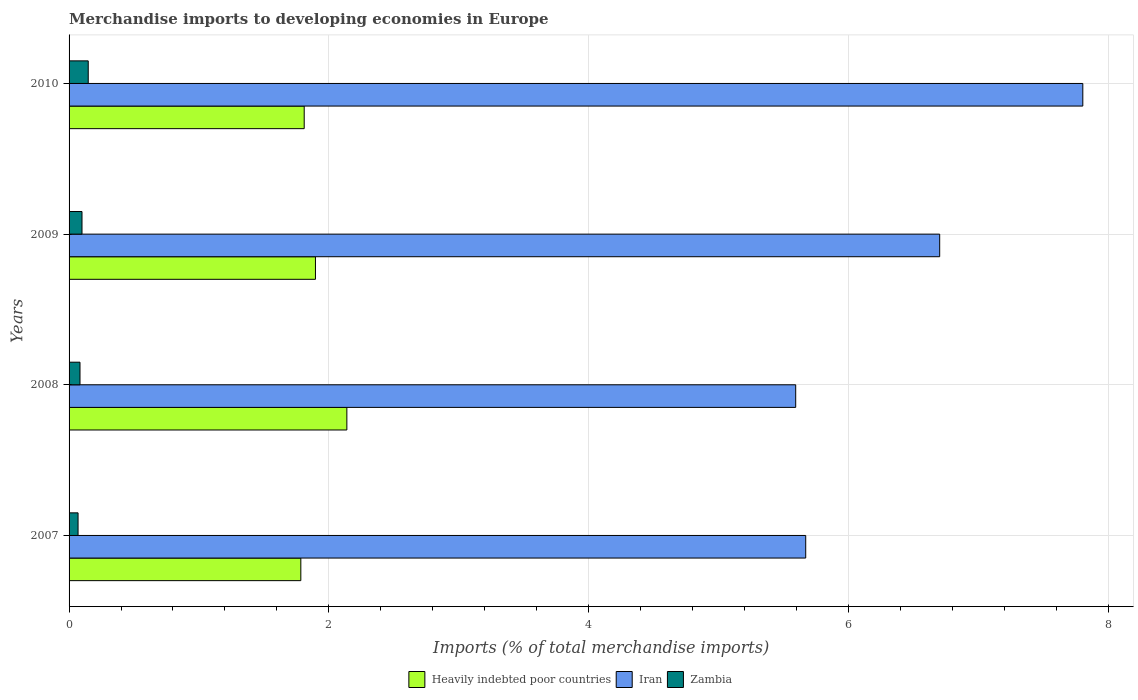Are the number of bars per tick equal to the number of legend labels?
Offer a terse response. Yes. What is the label of the 2nd group of bars from the top?
Keep it short and to the point. 2009. What is the percentage total merchandise imports in Heavily indebted poor countries in 2010?
Give a very brief answer. 1.81. Across all years, what is the maximum percentage total merchandise imports in Zambia?
Make the answer very short. 0.15. Across all years, what is the minimum percentage total merchandise imports in Zambia?
Give a very brief answer. 0.07. In which year was the percentage total merchandise imports in Zambia maximum?
Your response must be concise. 2010. In which year was the percentage total merchandise imports in Zambia minimum?
Offer a terse response. 2007. What is the total percentage total merchandise imports in Iran in the graph?
Make the answer very short. 25.78. What is the difference between the percentage total merchandise imports in Heavily indebted poor countries in 2007 and that in 2010?
Ensure brevity in your answer.  -0.03. What is the difference between the percentage total merchandise imports in Zambia in 2008 and the percentage total merchandise imports in Iran in 2007?
Provide a succinct answer. -5.59. What is the average percentage total merchandise imports in Iran per year?
Your response must be concise. 6.44. In the year 2010, what is the difference between the percentage total merchandise imports in Heavily indebted poor countries and percentage total merchandise imports in Iran?
Ensure brevity in your answer.  -6. In how many years, is the percentage total merchandise imports in Zambia greater than 6.4 %?
Offer a terse response. 0. What is the ratio of the percentage total merchandise imports in Heavily indebted poor countries in 2008 to that in 2010?
Make the answer very short. 1.18. Is the percentage total merchandise imports in Iran in 2007 less than that in 2010?
Ensure brevity in your answer.  Yes. What is the difference between the highest and the second highest percentage total merchandise imports in Iran?
Your answer should be compact. 1.1. What is the difference between the highest and the lowest percentage total merchandise imports in Zambia?
Ensure brevity in your answer.  0.08. Is the sum of the percentage total merchandise imports in Iran in 2007 and 2009 greater than the maximum percentage total merchandise imports in Heavily indebted poor countries across all years?
Your response must be concise. Yes. What does the 1st bar from the top in 2010 represents?
Provide a succinct answer. Zambia. What does the 3rd bar from the bottom in 2010 represents?
Make the answer very short. Zambia. How many bars are there?
Make the answer very short. 12. Does the graph contain grids?
Your response must be concise. Yes. What is the title of the graph?
Your response must be concise. Merchandise imports to developing economies in Europe. Does "Central Europe" appear as one of the legend labels in the graph?
Provide a short and direct response. No. What is the label or title of the X-axis?
Ensure brevity in your answer.  Imports (% of total merchandise imports). What is the label or title of the Y-axis?
Offer a very short reply. Years. What is the Imports (% of total merchandise imports) of Heavily indebted poor countries in 2007?
Your answer should be very brief. 1.78. What is the Imports (% of total merchandise imports) of Iran in 2007?
Make the answer very short. 5.67. What is the Imports (% of total merchandise imports) of Zambia in 2007?
Keep it short and to the point. 0.07. What is the Imports (% of total merchandise imports) in Heavily indebted poor countries in 2008?
Your answer should be very brief. 2.14. What is the Imports (% of total merchandise imports) in Iran in 2008?
Offer a very short reply. 5.6. What is the Imports (% of total merchandise imports) of Zambia in 2008?
Provide a short and direct response. 0.08. What is the Imports (% of total merchandise imports) of Heavily indebted poor countries in 2009?
Offer a very short reply. 1.9. What is the Imports (% of total merchandise imports) in Iran in 2009?
Your answer should be very brief. 6.7. What is the Imports (% of total merchandise imports) of Zambia in 2009?
Your response must be concise. 0.1. What is the Imports (% of total merchandise imports) in Heavily indebted poor countries in 2010?
Your answer should be very brief. 1.81. What is the Imports (% of total merchandise imports) in Iran in 2010?
Your response must be concise. 7.81. What is the Imports (% of total merchandise imports) of Zambia in 2010?
Your answer should be compact. 0.15. Across all years, what is the maximum Imports (% of total merchandise imports) of Heavily indebted poor countries?
Make the answer very short. 2.14. Across all years, what is the maximum Imports (% of total merchandise imports) in Iran?
Offer a terse response. 7.81. Across all years, what is the maximum Imports (% of total merchandise imports) in Zambia?
Provide a succinct answer. 0.15. Across all years, what is the minimum Imports (% of total merchandise imports) of Heavily indebted poor countries?
Provide a succinct answer. 1.78. Across all years, what is the minimum Imports (% of total merchandise imports) in Iran?
Ensure brevity in your answer.  5.6. Across all years, what is the minimum Imports (% of total merchandise imports) of Zambia?
Give a very brief answer. 0.07. What is the total Imports (% of total merchandise imports) of Heavily indebted poor countries in the graph?
Provide a short and direct response. 7.63. What is the total Imports (% of total merchandise imports) of Iran in the graph?
Make the answer very short. 25.78. What is the total Imports (% of total merchandise imports) of Zambia in the graph?
Provide a succinct answer. 0.4. What is the difference between the Imports (% of total merchandise imports) in Heavily indebted poor countries in 2007 and that in 2008?
Make the answer very short. -0.35. What is the difference between the Imports (% of total merchandise imports) of Iran in 2007 and that in 2008?
Your response must be concise. 0.08. What is the difference between the Imports (% of total merchandise imports) of Zambia in 2007 and that in 2008?
Ensure brevity in your answer.  -0.01. What is the difference between the Imports (% of total merchandise imports) in Heavily indebted poor countries in 2007 and that in 2009?
Make the answer very short. -0.11. What is the difference between the Imports (% of total merchandise imports) of Iran in 2007 and that in 2009?
Provide a succinct answer. -1.03. What is the difference between the Imports (% of total merchandise imports) of Zambia in 2007 and that in 2009?
Make the answer very short. -0.03. What is the difference between the Imports (% of total merchandise imports) of Heavily indebted poor countries in 2007 and that in 2010?
Offer a very short reply. -0.03. What is the difference between the Imports (% of total merchandise imports) of Iran in 2007 and that in 2010?
Offer a terse response. -2.13. What is the difference between the Imports (% of total merchandise imports) in Zambia in 2007 and that in 2010?
Give a very brief answer. -0.08. What is the difference between the Imports (% of total merchandise imports) in Heavily indebted poor countries in 2008 and that in 2009?
Provide a succinct answer. 0.24. What is the difference between the Imports (% of total merchandise imports) of Iran in 2008 and that in 2009?
Ensure brevity in your answer.  -1.11. What is the difference between the Imports (% of total merchandise imports) in Zambia in 2008 and that in 2009?
Give a very brief answer. -0.02. What is the difference between the Imports (% of total merchandise imports) of Heavily indebted poor countries in 2008 and that in 2010?
Provide a short and direct response. 0.33. What is the difference between the Imports (% of total merchandise imports) of Iran in 2008 and that in 2010?
Keep it short and to the point. -2.21. What is the difference between the Imports (% of total merchandise imports) in Zambia in 2008 and that in 2010?
Offer a terse response. -0.06. What is the difference between the Imports (% of total merchandise imports) in Heavily indebted poor countries in 2009 and that in 2010?
Your answer should be compact. 0.09. What is the difference between the Imports (% of total merchandise imports) of Iran in 2009 and that in 2010?
Keep it short and to the point. -1.1. What is the difference between the Imports (% of total merchandise imports) in Zambia in 2009 and that in 2010?
Your answer should be very brief. -0.05. What is the difference between the Imports (% of total merchandise imports) of Heavily indebted poor countries in 2007 and the Imports (% of total merchandise imports) of Iran in 2008?
Your answer should be very brief. -3.81. What is the difference between the Imports (% of total merchandise imports) of Heavily indebted poor countries in 2007 and the Imports (% of total merchandise imports) of Zambia in 2008?
Your response must be concise. 1.7. What is the difference between the Imports (% of total merchandise imports) in Iran in 2007 and the Imports (% of total merchandise imports) in Zambia in 2008?
Ensure brevity in your answer.  5.59. What is the difference between the Imports (% of total merchandise imports) in Heavily indebted poor countries in 2007 and the Imports (% of total merchandise imports) in Iran in 2009?
Your answer should be very brief. -4.92. What is the difference between the Imports (% of total merchandise imports) of Heavily indebted poor countries in 2007 and the Imports (% of total merchandise imports) of Zambia in 2009?
Provide a short and direct response. 1.69. What is the difference between the Imports (% of total merchandise imports) of Iran in 2007 and the Imports (% of total merchandise imports) of Zambia in 2009?
Keep it short and to the point. 5.57. What is the difference between the Imports (% of total merchandise imports) of Heavily indebted poor countries in 2007 and the Imports (% of total merchandise imports) of Iran in 2010?
Give a very brief answer. -6.02. What is the difference between the Imports (% of total merchandise imports) in Heavily indebted poor countries in 2007 and the Imports (% of total merchandise imports) in Zambia in 2010?
Ensure brevity in your answer.  1.64. What is the difference between the Imports (% of total merchandise imports) of Iran in 2007 and the Imports (% of total merchandise imports) of Zambia in 2010?
Your answer should be very brief. 5.52. What is the difference between the Imports (% of total merchandise imports) of Heavily indebted poor countries in 2008 and the Imports (% of total merchandise imports) of Iran in 2009?
Your answer should be compact. -4.56. What is the difference between the Imports (% of total merchandise imports) of Heavily indebted poor countries in 2008 and the Imports (% of total merchandise imports) of Zambia in 2009?
Provide a short and direct response. 2.04. What is the difference between the Imports (% of total merchandise imports) of Iran in 2008 and the Imports (% of total merchandise imports) of Zambia in 2009?
Make the answer very short. 5.5. What is the difference between the Imports (% of total merchandise imports) in Heavily indebted poor countries in 2008 and the Imports (% of total merchandise imports) in Iran in 2010?
Provide a short and direct response. -5.67. What is the difference between the Imports (% of total merchandise imports) of Heavily indebted poor countries in 2008 and the Imports (% of total merchandise imports) of Zambia in 2010?
Give a very brief answer. 1.99. What is the difference between the Imports (% of total merchandise imports) in Iran in 2008 and the Imports (% of total merchandise imports) in Zambia in 2010?
Your response must be concise. 5.45. What is the difference between the Imports (% of total merchandise imports) in Heavily indebted poor countries in 2009 and the Imports (% of total merchandise imports) in Iran in 2010?
Offer a very short reply. -5.91. What is the difference between the Imports (% of total merchandise imports) of Heavily indebted poor countries in 2009 and the Imports (% of total merchandise imports) of Zambia in 2010?
Keep it short and to the point. 1.75. What is the difference between the Imports (% of total merchandise imports) in Iran in 2009 and the Imports (% of total merchandise imports) in Zambia in 2010?
Ensure brevity in your answer.  6.56. What is the average Imports (% of total merchandise imports) in Heavily indebted poor countries per year?
Give a very brief answer. 1.91. What is the average Imports (% of total merchandise imports) in Iran per year?
Your answer should be compact. 6.44. What is the average Imports (% of total merchandise imports) of Zambia per year?
Make the answer very short. 0.1. In the year 2007, what is the difference between the Imports (% of total merchandise imports) in Heavily indebted poor countries and Imports (% of total merchandise imports) in Iran?
Your answer should be very brief. -3.89. In the year 2007, what is the difference between the Imports (% of total merchandise imports) of Heavily indebted poor countries and Imports (% of total merchandise imports) of Zambia?
Your response must be concise. 1.72. In the year 2007, what is the difference between the Imports (% of total merchandise imports) of Iran and Imports (% of total merchandise imports) of Zambia?
Provide a short and direct response. 5.6. In the year 2008, what is the difference between the Imports (% of total merchandise imports) of Heavily indebted poor countries and Imports (% of total merchandise imports) of Iran?
Your answer should be very brief. -3.46. In the year 2008, what is the difference between the Imports (% of total merchandise imports) in Heavily indebted poor countries and Imports (% of total merchandise imports) in Zambia?
Your answer should be compact. 2.05. In the year 2008, what is the difference between the Imports (% of total merchandise imports) in Iran and Imports (% of total merchandise imports) in Zambia?
Your answer should be compact. 5.51. In the year 2009, what is the difference between the Imports (% of total merchandise imports) of Heavily indebted poor countries and Imports (% of total merchandise imports) of Iran?
Make the answer very short. -4.81. In the year 2009, what is the difference between the Imports (% of total merchandise imports) of Heavily indebted poor countries and Imports (% of total merchandise imports) of Zambia?
Provide a short and direct response. 1.8. In the year 2009, what is the difference between the Imports (% of total merchandise imports) of Iran and Imports (% of total merchandise imports) of Zambia?
Your answer should be very brief. 6.6. In the year 2010, what is the difference between the Imports (% of total merchandise imports) in Heavily indebted poor countries and Imports (% of total merchandise imports) in Iran?
Your answer should be very brief. -6. In the year 2010, what is the difference between the Imports (% of total merchandise imports) in Heavily indebted poor countries and Imports (% of total merchandise imports) in Zambia?
Your answer should be very brief. 1.66. In the year 2010, what is the difference between the Imports (% of total merchandise imports) in Iran and Imports (% of total merchandise imports) in Zambia?
Provide a short and direct response. 7.66. What is the ratio of the Imports (% of total merchandise imports) of Heavily indebted poor countries in 2007 to that in 2008?
Provide a succinct answer. 0.83. What is the ratio of the Imports (% of total merchandise imports) of Iran in 2007 to that in 2008?
Ensure brevity in your answer.  1.01. What is the ratio of the Imports (% of total merchandise imports) of Zambia in 2007 to that in 2008?
Give a very brief answer. 0.82. What is the ratio of the Imports (% of total merchandise imports) in Heavily indebted poor countries in 2007 to that in 2009?
Your answer should be very brief. 0.94. What is the ratio of the Imports (% of total merchandise imports) of Iran in 2007 to that in 2009?
Your answer should be very brief. 0.85. What is the ratio of the Imports (% of total merchandise imports) of Zambia in 2007 to that in 2009?
Provide a succinct answer. 0.7. What is the ratio of the Imports (% of total merchandise imports) in Heavily indebted poor countries in 2007 to that in 2010?
Provide a short and direct response. 0.99. What is the ratio of the Imports (% of total merchandise imports) of Iran in 2007 to that in 2010?
Offer a terse response. 0.73. What is the ratio of the Imports (% of total merchandise imports) of Zambia in 2007 to that in 2010?
Your answer should be very brief. 0.47. What is the ratio of the Imports (% of total merchandise imports) in Heavily indebted poor countries in 2008 to that in 2009?
Ensure brevity in your answer.  1.13. What is the ratio of the Imports (% of total merchandise imports) in Iran in 2008 to that in 2009?
Keep it short and to the point. 0.83. What is the ratio of the Imports (% of total merchandise imports) in Zambia in 2008 to that in 2009?
Keep it short and to the point. 0.85. What is the ratio of the Imports (% of total merchandise imports) of Heavily indebted poor countries in 2008 to that in 2010?
Your response must be concise. 1.18. What is the ratio of the Imports (% of total merchandise imports) in Iran in 2008 to that in 2010?
Offer a terse response. 0.72. What is the ratio of the Imports (% of total merchandise imports) in Zambia in 2008 to that in 2010?
Provide a short and direct response. 0.57. What is the ratio of the Imports (% of total merchandise imports) in Heavily indebted poor countries in 2009 to that in 2010?
Give a very brief answer. 1.05. What is the ratio of the Imports (% of total merchandise imports) of Iran in 2009 to that in 2010?
Your response must be concise. 0.86. What is the ratio of the Imports (% of total merchandise imports) in Zambia in 2009 to that in 2010?
Your answer should be very brief. 0.67. What is the difference between the highest and the second highest Imports (% of total merchandise imports) in Heavily indebted poor countries?
Offer a terse response. 0.24. What is the difference between the highest and the second highest Imports (% of total merchandise imports) in Iran?
Provide a short and direct response. 1.1. What is the difference between the highest and the second highest Imports (% of total merchandise imports) in Zambia?
Give a very brief answer. 0.05. What is the difference between the highest and the lowest Imports (% of total merchandise imports) in Heavily indebted poor countries?
Provide a succinct answer. 0.35. What is the difference between the highest and the lowest Imports (% of total merchandise imports) in Iran?
Give a very brief answer. 2.21. What is the difference between the highest and the lowest Imports (% of total merchandise imports) in Zambia?
Provide a succinct answer. 0.08. 